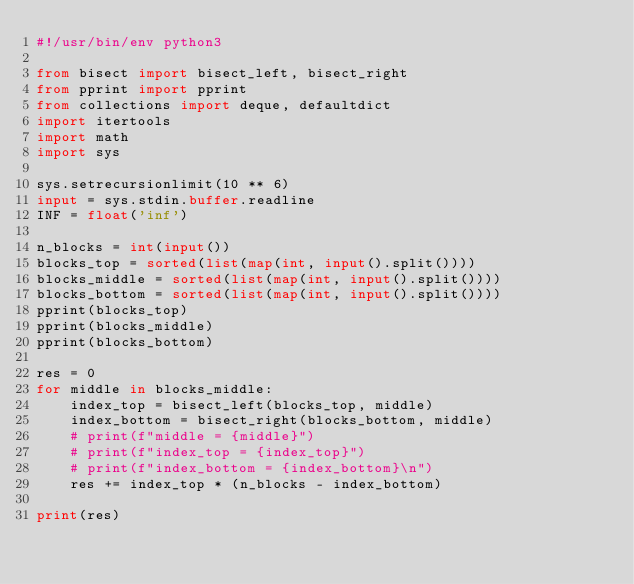<code> <loc_0><loc_0><loc_500><loc_500><_Python_>#!/usr/bin/env python3

from bisect import bisect_left, bisect_right
from pprint import pprint
from collections import deque, defaultdict
import itertools
import math
import sys

sys.setrecursionlimit(10 ** 6)
input = sys.stdin.buffer.readline
INF = float('inf')

n_blocks = int(input())
blocks_top = sorted(list(map(int, input().split())))
blocks_middle = sorted(list(map(int, input().split())))
blocks_bottom = sorted(list(map(int, input().split())))
pprint(blocks_top)
pprint(blocks_middle)
pprint(blocks_bottom)

res = 0
for middle in blocks_middle:
    index_top = bisect_left(blocks_top, middle)
    index_bottom = bisect_right(blocks_bottom, middle)
    # print(f"middle = {middle}")
    # print(f"index_top = {index_top}")
    # print(f"index_bottom = {index_bottom}\n")
    res += index_top * (n_blocks - index_bottom)

print(res)
</code> 